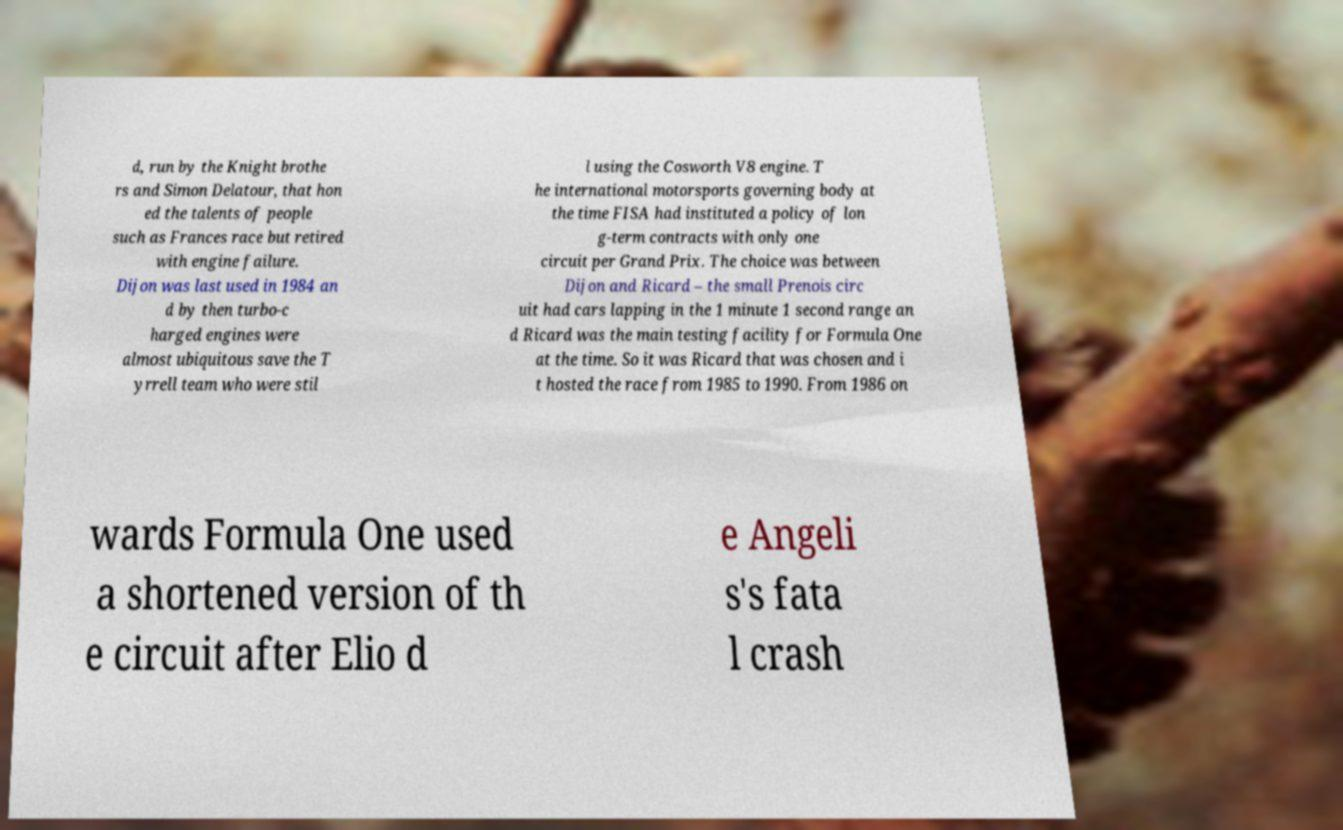Could you assist in decoding the text presented in this image and type it out clearly? d, run by the Knight brothe rs and Simon Delatour, that hon ed the talents of people such as Frances race but retired with engine failure. Dijon was last used in 1984 an d by then turbo-c harged engines were almost ubiquitous save the T yrrell team who were stil l using the Cosworth V8 engine. T he international motorsports governing body at the time FISA had instituted a policy of lon g-term contracts with only one circuit per Grand Prix. The choice was between Dijon and Ricard – the small Prenois circ uit had cars lapping in the 1 minute 1 second range an d Ricard was the main testing facility for Formula One at the time. So it was Ricard that was chosen and i t hosted the race from 1985 to 1990. From 1986 on wards Formula One used a shortened version of th e circuit after Elio d e Angeli s's fata l crash 